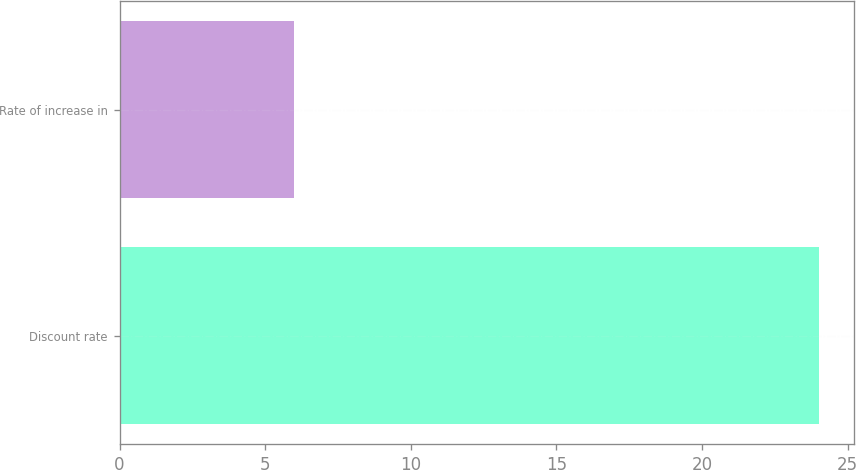Convert chart. <chart><loc_0><loc_0><loc_500><loc_500><bar_chart><fcel>Discount rate<fcel>Rate of increase in<nl><fcel>24<fcel>6<nl></chart> 